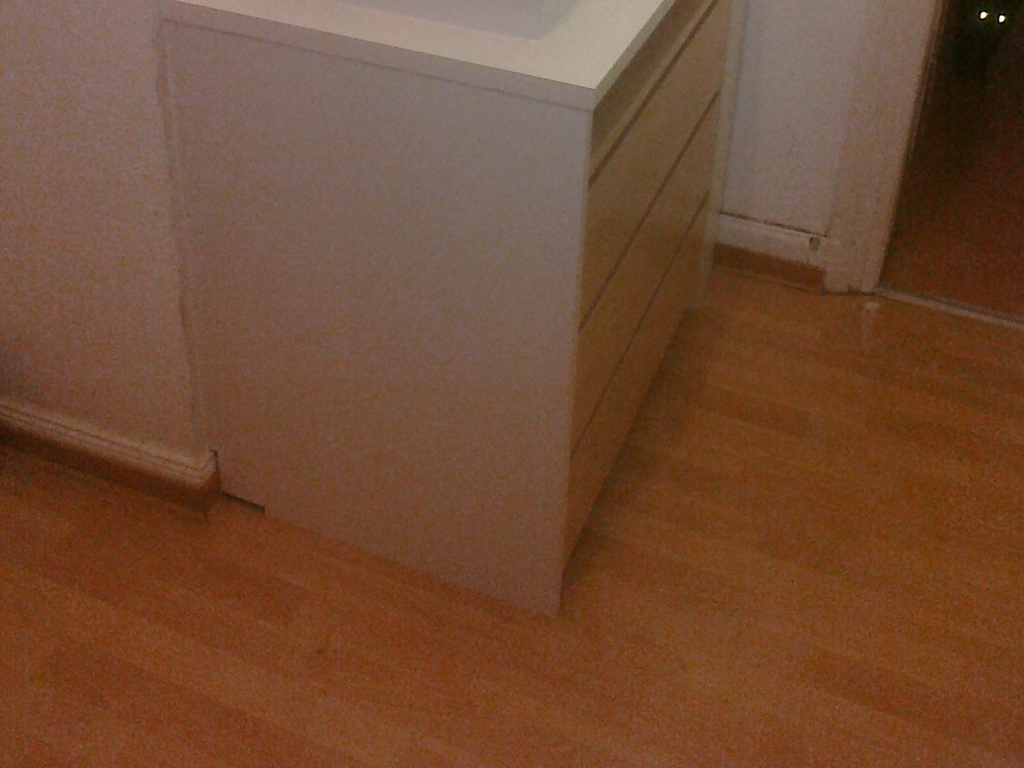What can be seen in this image?
A. Cabinet and floor
B. Colorful scenery
C. Detailed objects
Answer with the option's letter from the given choices directly.
 A. 